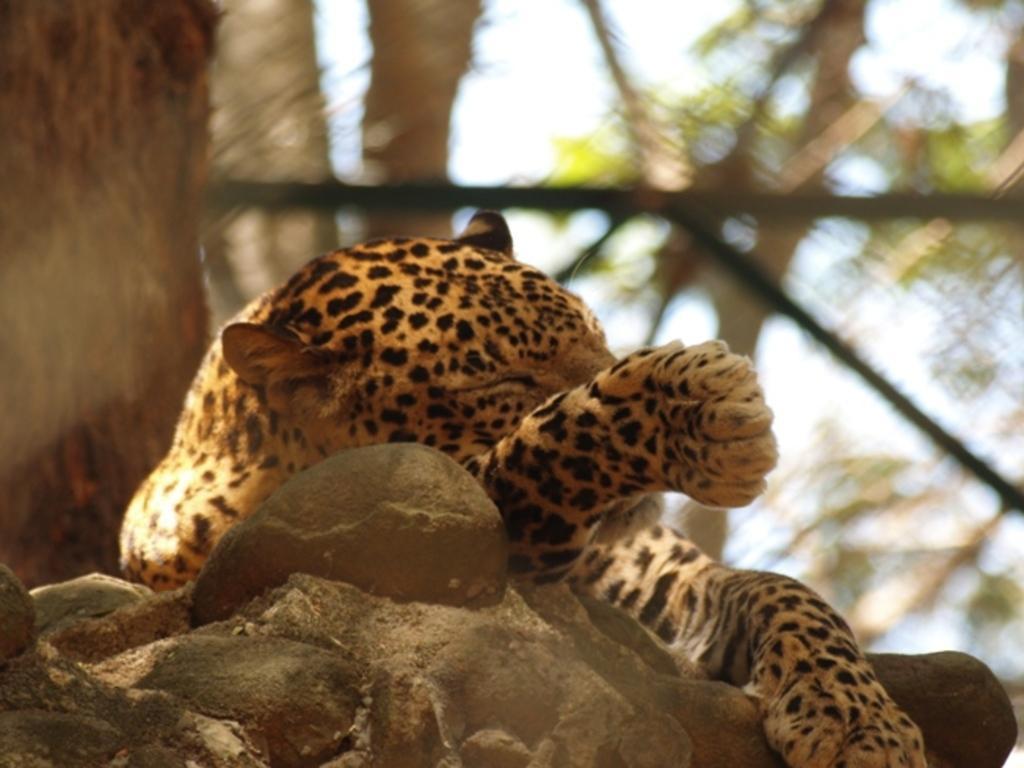Please provide a concise description of this image. In the image I can see a leopard. In the background I can see trees and some other objects. The background of the image is blurred. 